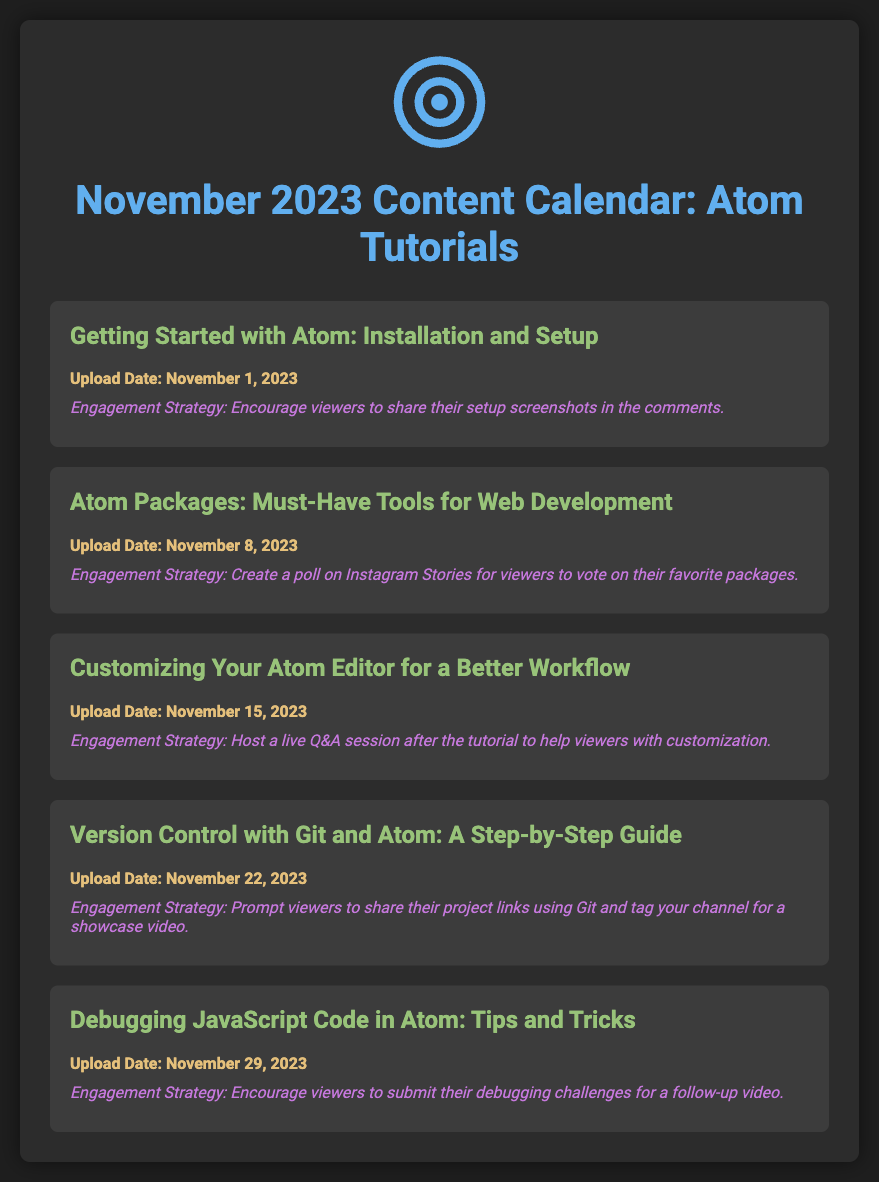what is the upload date for the first tutorial? The first tutorial titled "Getting Started with Atom: Installation and Setup" is scheduled for November 1, 2023.
Answer: November 1, 2023 what is the title of the third tutorial? The third tutorial is called "Customizing Your Atom Editor for a Better Workflow."
Answer: Customizing Your Atom Editor for a Better Workflow how many tutorials are scheduled for November 2023? There are a total of five tutorials listed in the content calendar for November 2023.
Answer: Five what is the engagement strategy for the second tutorial? The second tutorial's engagement strategy involves creating a poll on Instagram Stories for viewers to vote on their favorite packages.
Answer: Create a poll on Instagram Stories which tutorial includes live Q&A as an engagement strategy? The tutorial "Customizing Your Atom Editor for a Better Workflow" includes a live Q&A session as an engagement strategy.
Answer: Customizing Your Atom Editor for a Better Workflow what color is used for the tutorial titles? The tutorial titles are colored in a shade of green (#98C379).
Answer: Green on which date will the tutorial about version control be uploaded? The tutorial "Version Control with Git and Atom: A Step-by-Step Guide" will be uploaded on November 22, 2023.
Answer: November 22, 2023 what is the engagement strategy for the last tutorial? The engagement strategy for the last tutorial, "Debugging JavaScript Code in Atom: Tips and Tricks," is to encourage viewers to submit their debugging challenges.
Answer: Encourage viewers to submit their debugging challenges what icon is displayed at the top of the content calendar? The icon displayed at the top of the content calendar is an atom icon.
Answer: Atom icon 